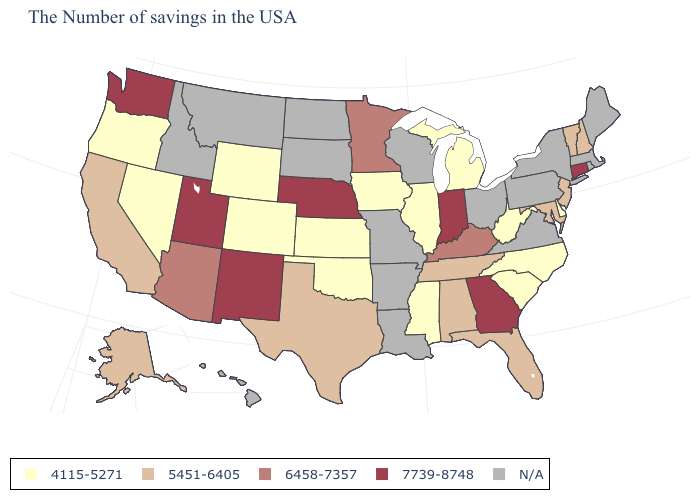What is the value of Minnesota?
Write a very short answer. 6458-7357. What is the value of South Carolina?
Be succinct. 4115-5271. Which states have the lowest value in the USA?
Concise answer only. Delaware, North Carolina, South Carolina, West Virginia, Michigan, Illinois, Mississippi, Iowa, Kansas, Oklahoma, Wyoming, Colorado, Nevada, Oregon. What is the lowest value in states that border Indiana?
Write a very short answer. 4115-5271. What is the value of Wyoming?
Be succinct. 4115-5271. What is the highest value in the MidWest ?
Keep it brief. 7739-8748. Which states have the highest value in the USA?
Give a very brief answer. Connecticut, Georgia, Indiana, Nebraska, New Mexico, Utah, Washington. What is the highest value in the USA?
Quick response, please. 7739-8748. Name the states that have a value in the range 7739-8748?
Give a very brief answer. Connecticut, Georgia, Indiana, Nebraska, New Mexico, Utah, Washington. Among the states that border New York , does Connecticut have the highest value?
Quick response, please. Yes. What is the value of Arkansas?
Answer briefly. N/A. What is the lowest value in the Northeast?
Quick response, please. 5451-6405. What is the value of Indiana?
Short answer required. 7739-8748. Name the states that have a value in the range 5451-6405?
Write a very short answer. New Hampshire, Vermont, New Jersey, Maryland, Florida, Alabama, Tennessee, Texas, California, Alaska. 